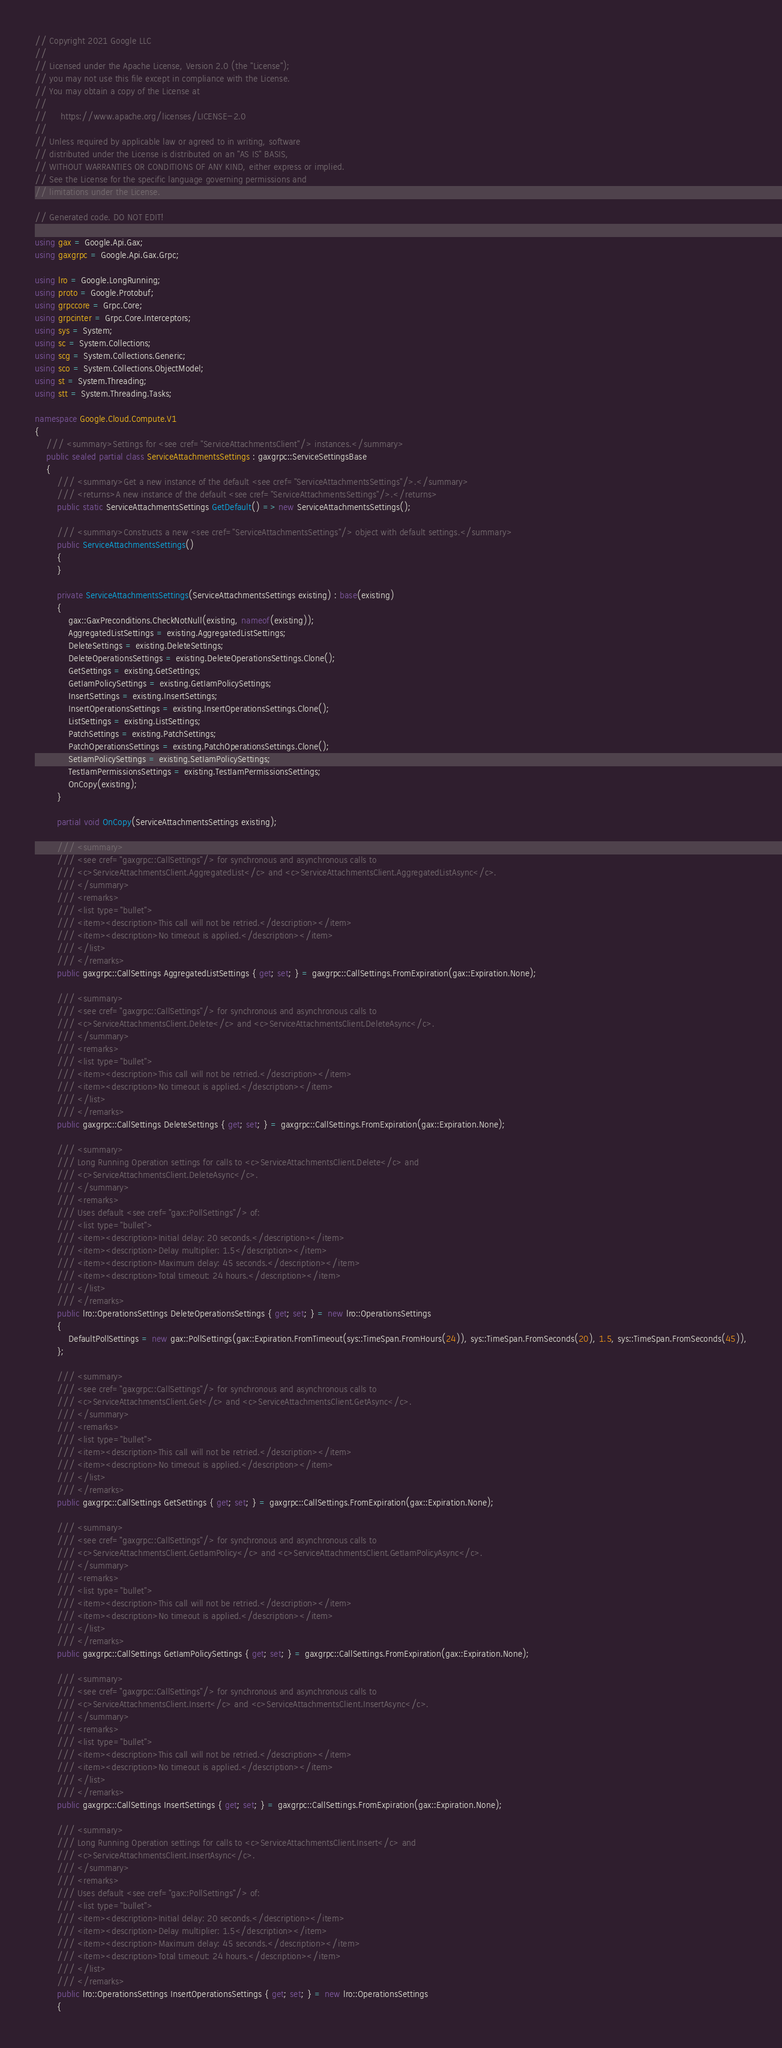<code> <loc_0><loc_0><loc_500><loc_500><_C#_>// Copyright 2021 Google LLC
//
// Licensed under the Apache License, Version 2.0 (the "License");
// you may not use this file except in compliance with the License.
// You may obtain a copy of the License at
//
//     https://www.apache.org/licenses/LICENSE-2.0
//
// Unless required by applicable law or agreed to in writing, software
// distributed under the License is distributed on an "AS IS" BASIS,
// WITHOUT WARRANTIES OR CONDITIONS OF ANY KIND, either express or implied.
// See the License for the specific language governing permissions and
// limitations under the License.

// Generated code. DO NOT EDIT!

using gax = Google.Api.Gax;
using gaxgrpc = Google.Api.Gax.Grpc;

using lro = Google.LongRunning;
using proto = Google.Protobuf;
using grpccore = Grpc.Core;
using grpcinter = Grpc.Core.Interceptors;
using sys = System;
using sc = System.Collections;
using scg = System.Collections.Generic;
using sco = System.Collections.ObjectModel;
using st = System.Threading;
using stt = System.Threading.Tasks;

namespace Google.Cloud.Compute.V1
{
    /// <summary>Settings for <see cref="ServiceAttachmentsClient"/> instances.</summary>
    public sealed partial class ServiceAttachmentsSettings : gaxgrpc::ServiceSettingsBase
    {
        /// <summary>Get a new instance of the default <see cref="ServiceAttachmentsSettings"/>.</summary>
        /// <returns>A new instance of the default <see cref="ServiceAttachmentsSettings"/>.</returns>
        public static ServiceAttachmentsSettings GetDefault() => new ServiceAttachmentsSettings();

        /// <summary>Constructs a new <see cref="ServiceAttachmentsSettings"/> object with default settings.</summary>
        public ServiceAttachmentsSettings()
        {
        }

        private ServiceAttachmentsSettings(ServiceAttachmentsSettings existing) : base(existing)
        {
            gax::GaxPreconditions.CheckNotNull(existing, nameof(existing));
            AggregatedListSettings = existing.AggregatedListSettings;
            DeleteSettings = existing.DeleteSettings;
            DeleteOperationsSettings = existing.DeleteOperationsSettings.Clone();
            GetSettings = existing.GetSettings;
            GetIamPolicySettings = existing.GetIamPolicySettings;
            InsertSettings = existing.InsertSettings;
            InsertOperationsSettings = existing.InsertOperationsSettings.Clone();
            ListSettings = existing.ListSettings;
            PatchSettings = existing.PatchSettings;
            PatchOperationsSettings = existing.PatchOperationsSettings.Clone();
            SetIamPolicySettings = existing.SetIamPolicySettings;
            TestIamPermissionsSettings = existing.TestIamPermissionsSettings;
            OnCopy(existing);
        }

        partial void OnCopy(ServiceAttachmentsSettings existing);

        /// <summary>
        /// <see cref="gaxgrpc::CallSettings"/> for synchronous and asynchronous calls to
        /// <c>ServiceAttachmentsClient.AggregatedList</c> and <c>ServiceAttachmentsClient.AggregatedListAsync</c>.
        /// </summary>
        /// <remarks>
        /// <list type="bullet">
        /// <item><description>This call will not be retried.</description></item>
        /// <item><description>No timeout is applied.</description></item>
        /// </list>
        /// </remarks>
        public gaxgrpc::CallSettings AggregatedListSettings { get; set; } = gaxgrpc::CallSettings.FromExpiration(gax::Expiration.None);

        /// <summary>
        /// <see cref="gaxgrpc::CallSettings"/> for synchronous and asynchronous calls to
        /// <c>ServiceAttachmentsClient.Delete</c> and <c>ServiceAttachmentsClient.DeleteAsync</c>.
        /// </summary>
        /// <remarks>
        /// <list type="bullet">
        /// <item><description>This call will not be retried.</description></item>
        /// <item><description>No timeout is applied.</description></item>
        /// </list>
        /// </remarks>
        public gaxgrpc::CallSettings DeleteSettings { get; set; } = gaxgrpc::CallSettings.FromExpiration(gax::Expiration.None);

        /// <summary>
        /// Long Running Operation settings for calls to <c>ServiceAttachmentsClient.Delete</c> and
        /// <c>ServiceAttachmentsClient.DeleteAsync</c>.
        /// </summary>
        /// <remarks>
        /// Uses default <see cref="gax::PollSettings"/> of:
        /// <list type="bullet">
        /// <item><description>Initial delay: 20 seconds.</description></item>
        /// <item><description>Delay multiplier: 1.5</description></item>
        /// <item><description>Maximum delay: 45 seconds.</description></item>
        /// <item><description>Total timeout: 24 hours.</description></item>
        /// </list>
        /// </remarks>
        public lro::OperationsSettings DeleteOperationsSettings { get; set; } = new lro::OperationsSettings
        {
            DefaultPollSettings = new gax::PollSettings(gax::Expiration.FromTimeout(sys::TimeSpan.FromHours(24)), sys::TimeSpan.FromSeconds(20), 1.5, sys::TimeSpan.FromSeconds(45)),
        };

        /// <summary>
        /// <see cref="gaxgrpc::CallSettings"/> for synchronous and asynchronous calls to
        /// <c>ServiceAttachmentsClient.Get</c> and <c>ServiceAttachmentsClient.GetAsync</c>.
        /// </summary>
        /// <remarks>
        /// <list type="bullet">
        /// <item><description>This call will not be retried.</description></item>
        /// <item><description>No timeout is applied.</description></item>
        /// </list>
        /// </remarks>
        public gaxgrpc::CallSettings GetSettings { get; set; } = gaxgrpc::CallSettings.FromExpiration(gax::Expiration.None);

        /// <summary>
        /// <see cref="gaxgrpc::CallSettings"/> for synchronous and asynchronous calls to
        /// <c>ServiceAttachmentsClient.GetIamPolicy</c> and <c>ServiceAttachmentsClient.GetIamPolicyAsync</c>.
        /// </summary>
        /// <remarks>
        /// <list type="bullet">
        /// <item><description>This call will not be retried.</description></item>
        /// <item><description>No timeout is applied.</description></item>
        /// </list>
        /// </remarks>
        public gaxgrpc::CallSettings GetIamPolicySettings { get; set; } = gaxgrpc::CallSettings.FromExpiration(gax::Expiration.None);

        /// <summary>
        /// <see cref="gaxgrpc::CallSettings"/> for synchronous and asynchronous calls to
        /// <c>ServiceAttachmentsClient.Insert</c> and <c>ServiceAttachmentsClient.InsertAsync</c>.
        /// </summary>
        /// <remarks>
        /// <list type="bullet">
        /// <item><description>This call will not be retried.</description></item>
        /// <item><description>No timeout is applied.</description></item>
        /// </list>
        /// </remarks>
        public gaxgrpc::CallSettings InsertSettings { get; set; } = gaxgrpc::CallSettings.FromExpiration(gax::Expiration.None);

        /// <summary>
        /// Long Running Operation settings for calls to <c>ServiceAttachmentsClient.Insert</c> and
        /// <c>ServiceAttachmentsClient.InsertAsync</c>.
        /// </summary>
        /// <remarks>
        /// Uses default <see cref="gax::PollSettings"/> of:
        /// <list type="bullet">
        /// <item><description>Initial delay: 20 seconds.</description></item>
        /// <item><description>Delay multiplier: 1.5</description></item>
        /// <item><description>Maximum delay: 45 seconds.</description></item>
        /// <item><description>Total timeout: 24 hours.</description></item>
        /// </list>
        /// </remarks>
        public lro::OperationsSettings InsertOperationsSettings { get; set; } = new lro::OperationsSettings
        {</code> 